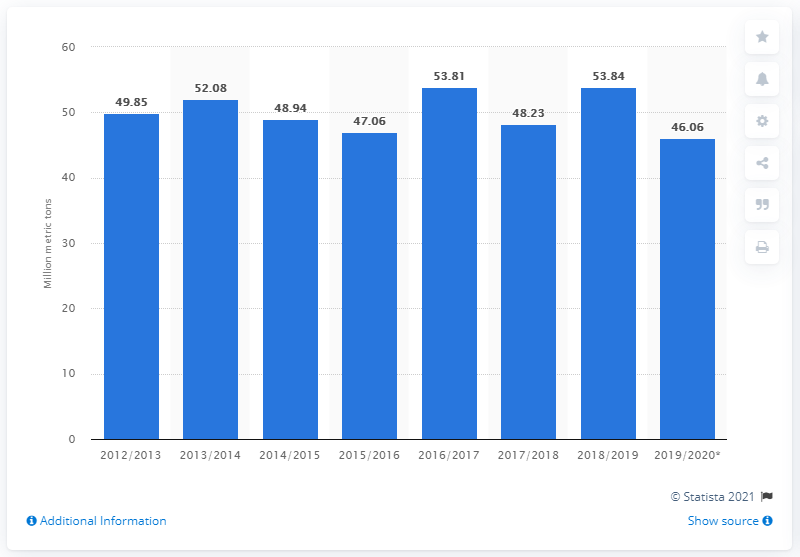Mention a couple of crucial points in this snapshot. In the 2018/2019 crop year, the global production of oranges was 53.84 million metric tons. The estimated decrease in global orange production for the 2019/2020 season is approximately 46.06 million tons. 